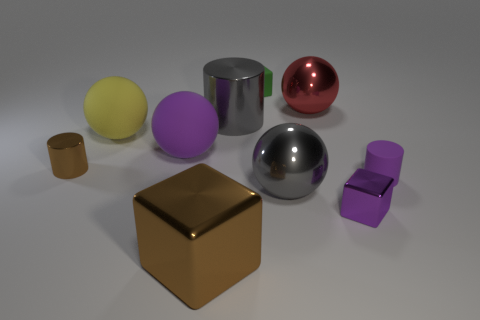There is a large matte thing that is the same color as the matte cylinder; what shape is it?
Your response must be concise. Sphere. The small cylinder that is right of the brown shiny thing that is in front of the shiny cylinder to the left of the large metal cylinder is what color?
Offer a terse response. Purple. What number of tiny red rubber things are the same shape as the tiny purple rubber thing?
Your answer should be very brief. 0. What size is the gray thing that is in front of the purple thing that is behind the small shiny cylinder?
Offer a very short reply. Large. Does the yellow matte object have the same size as the brown block?
Offer a terse response. Yes. Are there any cylinders that are in front of the brown metallic thing that is to the left of the brown metallic thing that is on the right side of the large purple object?
Make the answer very short. Yes. How big is the brown cylinder?
Ensure brevity in your answer.  Small. How many gray balls are the same size as the gray metal cylinder?
Give a very brief answer. 1. There is a purple thing that is the same shape as the large yellow matte object; what material is it?
Offer a very short reply. Rubber. What shape is the purple thing that is both on the left side of the purple rubber cylinder and behind the small metal block?
Your answer should be very brief. Sphere. 